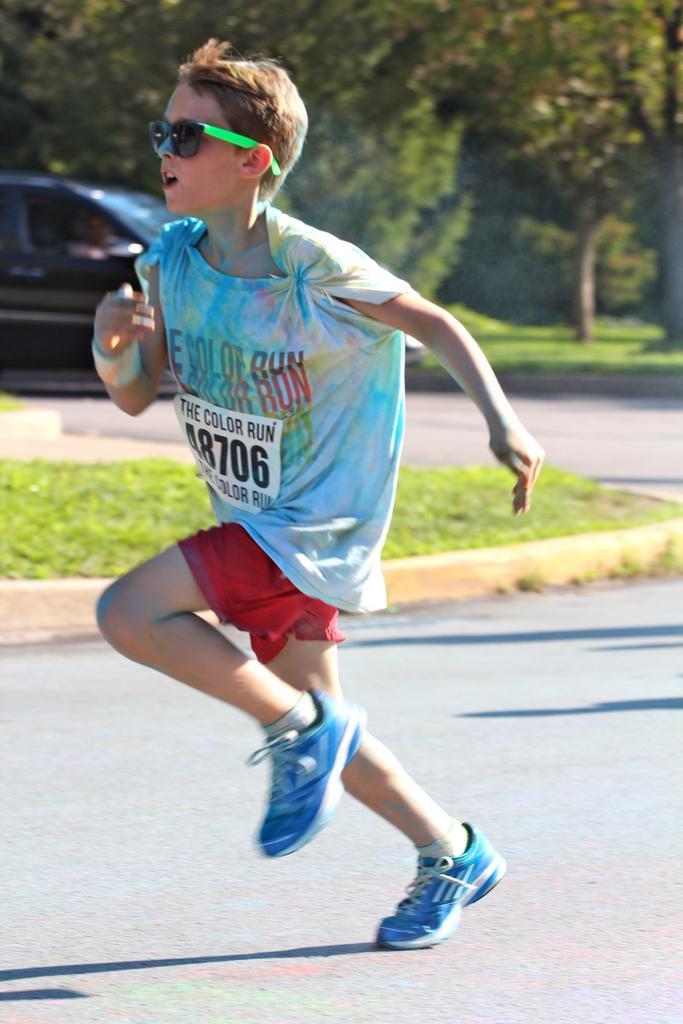Can you describe this image briefly? In this image, I can see a boy running on the road. In the background, there are trees, a vehicle and the grass. 